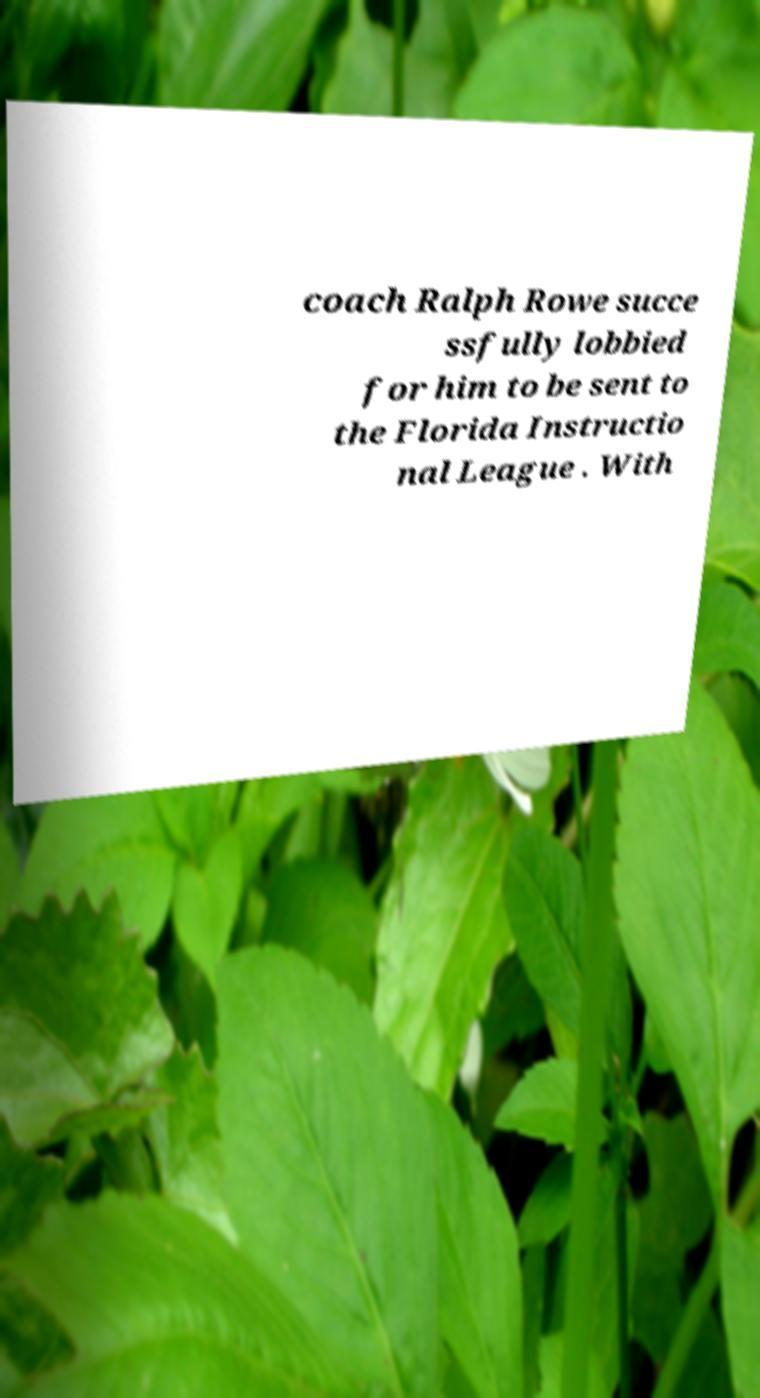For documentation purposes, I need the text within this image transcribed. Could you provide that? coach Ralph Rowe succe ssfully lobbied for him to be sent to the Florida Instructio nal League . With 